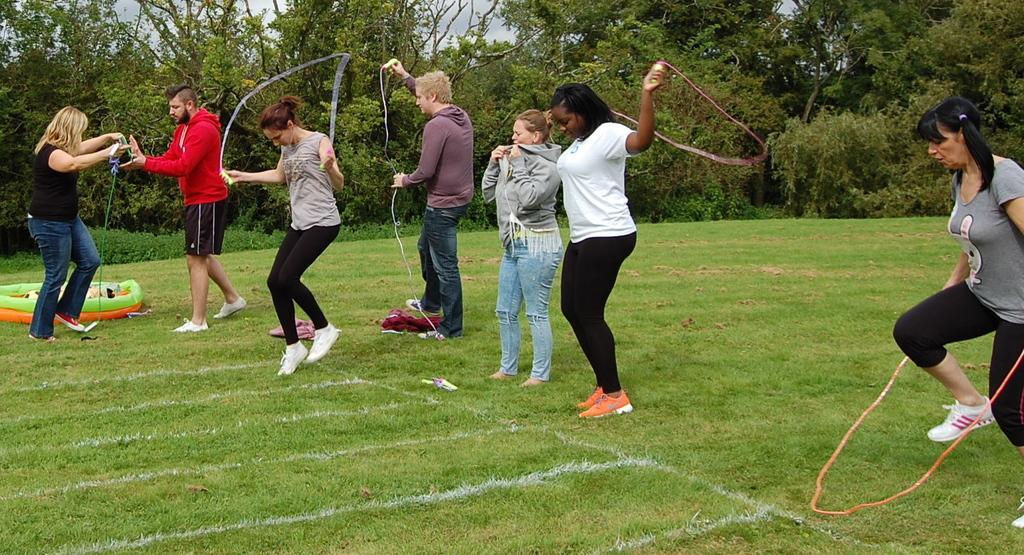Describe this image in one or two sentences. In this picture we can see a group of people,some people are skipping with ropes and in the background we can see trees,sky. 